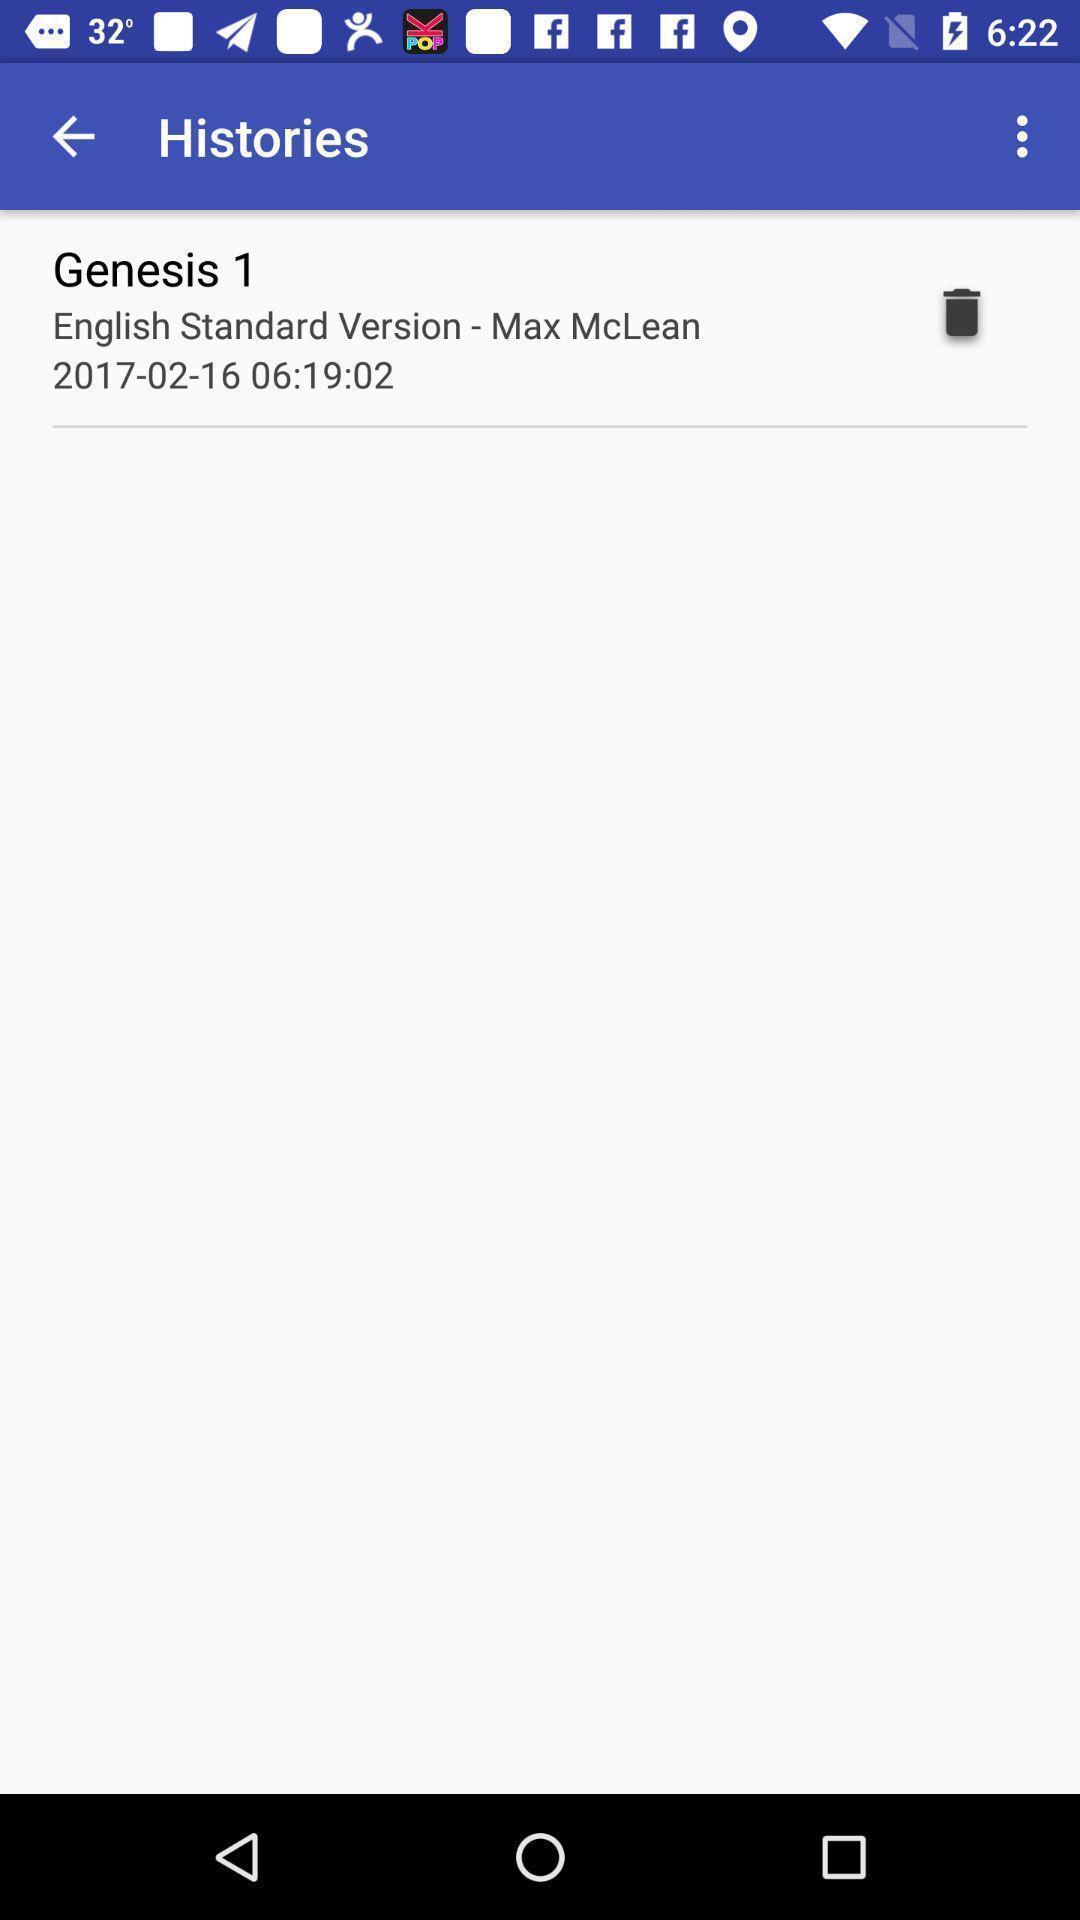Tell me what you see in this picture. Page is showing histories. 